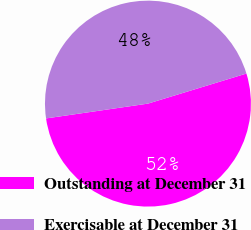Convert chart to OTSL. <chart><loc_0><loc_0><loc_500><loc_500><pie_chart><fcel>Outstanding at December 31<fcel>Exercisable at December 31<nl><fcel>52.42%<fcel>47.58%<nl></chart> 